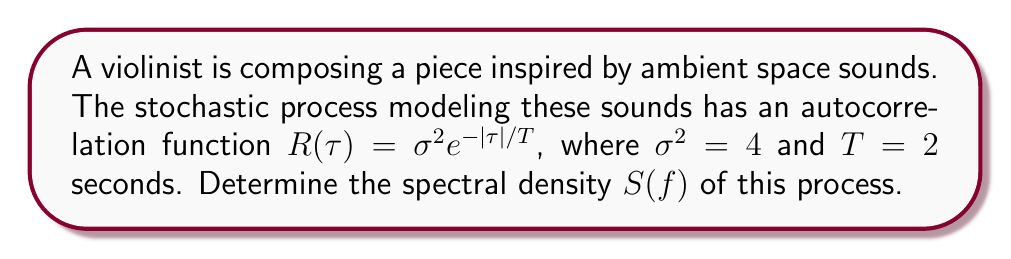Show me your answer to this math problem. To determine the spectral density $S(f)$ of the stochastic process, we'll follow these steps:

1) The spectral density is the Fourier transform of the autocorrelation function. For a real and even autocorrelation function, we can use the cosine transform:

   $$S(f) = 2 \int_0^{\infty} R(\tau) \cos(2\pi f \tau) d\tau$$

2) Substitute the given autocorrelation function:

   $$S(f) = 2 \int_0^{\infty} 4e^{-\tau/2} \cos(2\pi f \tau) d\tau$$

3) This integral can be solved using the following standard result:

   $$\int_0^{\infty} e^{-a\tau} \cos(b\tau) d\tau = \frac{a}{a^2 + b^2}$$

4) In our case, $a = 1/2$ and $b = 2\pi f$. Applying this result:

   $$S(f) = 2 \cdot 4 \cdot \frac{1/2}{(1/2)^2 + (2\pi f)^2}$$

5) Simplify:

   $$S(f) = \frac{4}{1/4 + 4\pi^2f^2}$$

6) Further simplification:

   $$S(f) = \frac{16}{1 + 16\pi^2f^2}$$

This is the spectral density function for the given stochastic process.
Answer: $$S(f) = \frac{16}{1 + 16\pi^2f^2}$$ 